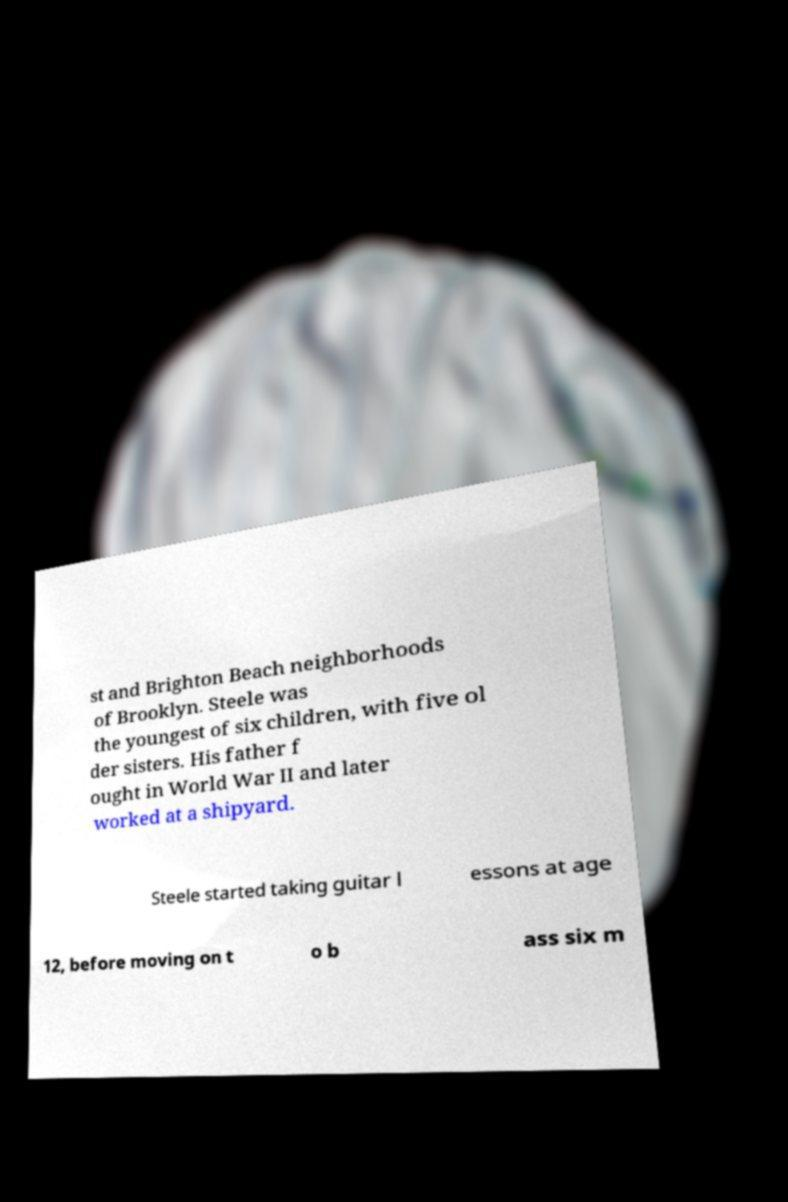For documentation purposes, I need the text within this image transcribed. Could you provide that? st and Brighton Beach neighborhoods of Brooklyn. Steele was the youngest of six children, with five ol der sisters. His father f ought in World War II and later worked at a shipyard. Steele started taking guitar l essons at age 12, before moving on t o b ass six m 